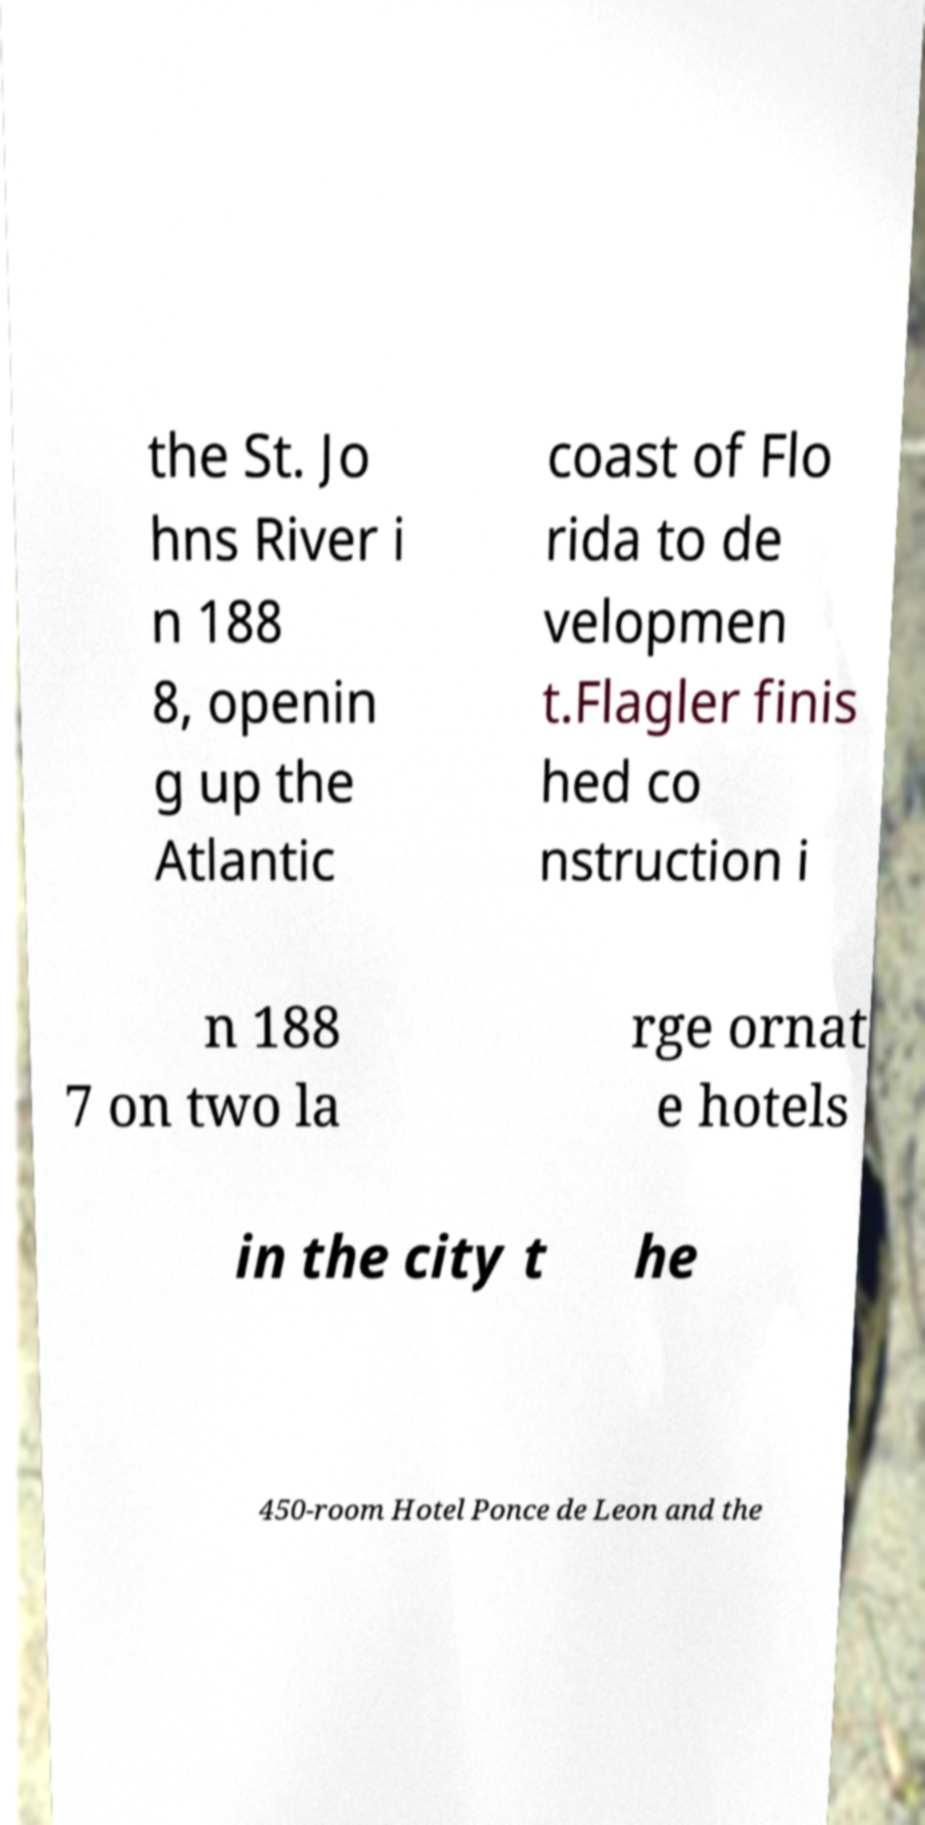Could you extract and type out the text from this image? the St. Jo hns River i n 188 8, openin g up the Atlantic coast of Flo rida to de velopmen t.Flagler finis hed co nstruction i n 188 7 on two la rge ornat e hotels in the city t he 450-room Hotel Ponce de Leon and the 